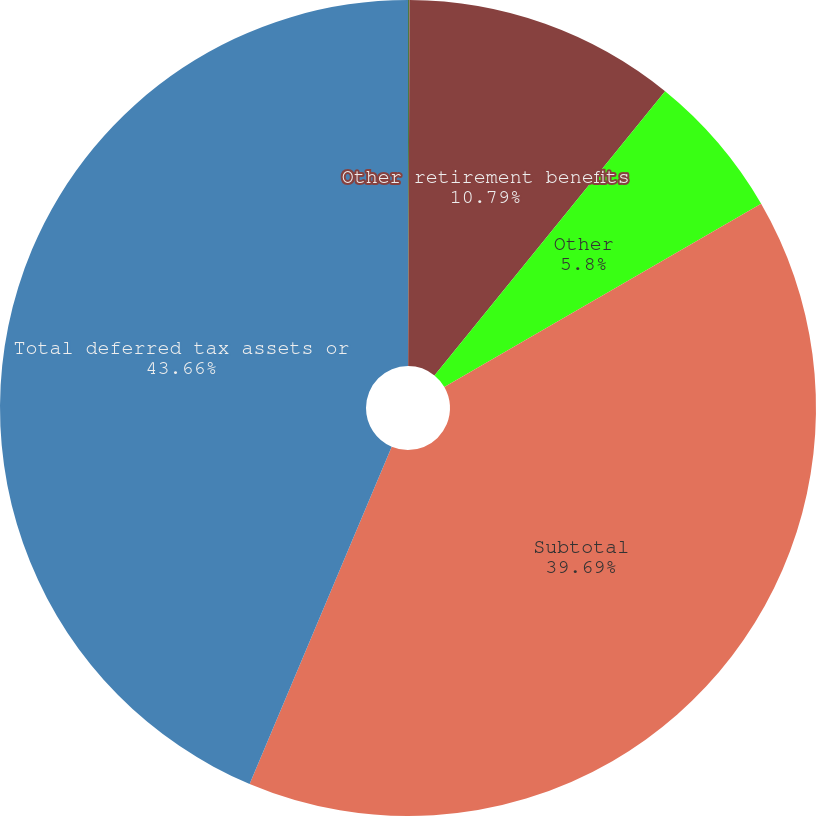Convert chart to OTSL. <chart><loc_0><loc_0><loc_500><loc_500><pie_chart><fcel>Warranty reserves<fcel>Other retirement benefits<fcel>Other<fcel>Subtotal<fcel>Total deferred tax assets or<nl><fcel>0.06%<fcel>10.79%<fcel>5.8%<fcel>39.69%<fcel>43.65%<nl></chart> 